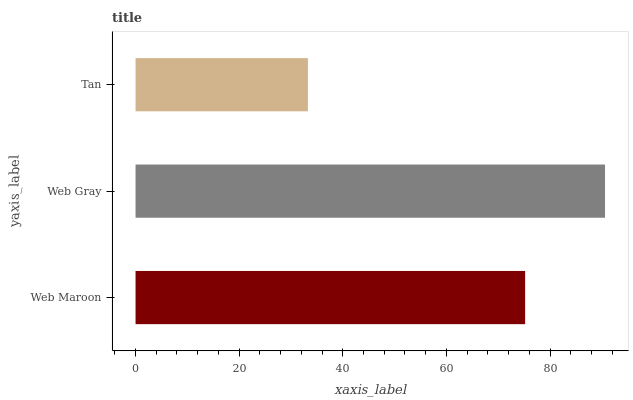Is Tan the minimum?
Answer yes or no. Yes. Is Web Gray the maximum?
Answer yes or no. Yes. Is Web Gray the minimum?
Answer yes or no. No. Is Tan the maximum?
Answer yes or no. No. Is Web Gray greater than Tan?
Answer yes or no. Yes. Is Tan less than Web Gray?
Answer yes or no. Yes. Is Tan greater than Web Gray?
Answer yes or no. No. Is Web Gray less than Tan?
Answer yes or no. No. Is Web Maroon the high median?
Answer yes or no. Yes. Is Web Maroon the low median?
Answer yes or no. Yes. Is Tan the high median?
Answer yes or no. No. Is Web Gray the low median?
Answer yes or no. No. 